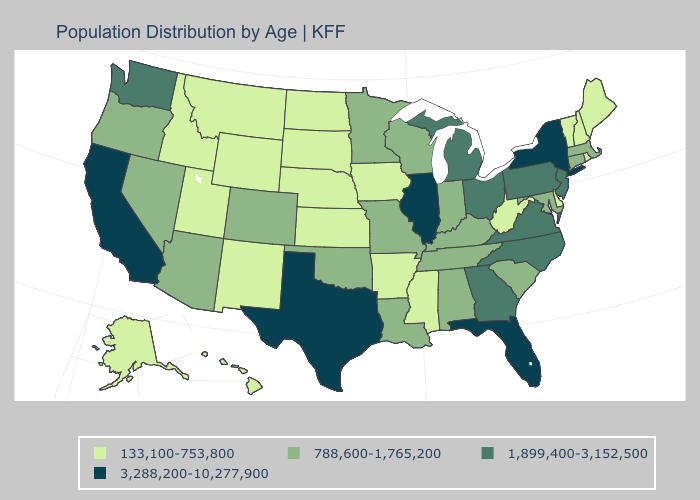Does Illinois have the highest value in the MidWest?
Keep it brief. Yes. How many symbols are there in the legend?
Answer briefly. 4. Does Texas have the same value as Alabama?
Be succinct. No. Does Nevada have a lower value than Pennsylvania?
Short answer required. Yes. What is the highest value in states that border Kansas?
Write a very short answer. 788,600-1,765,200. What is the value of Iowa?
Quick response, please. 133,100-753,800. Does California have the highest value in the USA?
Answer briefly. Yes. Among the states that border Wisconsin , does Michigan have the lowest value?
Quick response, please. No. What is the value of Missouri?
Answer briefly. 788,600-1,765,200. What is the highest value in states that border Ohio?
Write a very short answer. 1,899,400-3,152,500. What is the highest value in the USA?
Be succinct. 3,288,200-10,277,900. What is the highest value in states that border Texas?
Short answer required. 788,600-1,765,200. Does Wisconsin have the lowest value in the USA?
Keep it brief. No. Which states hav the highest value in the Northeast?
Keep it brief. New York. Among the states that border Maryland , which have the lowest value?
Answer briefly. Delaware, West Virginia. 